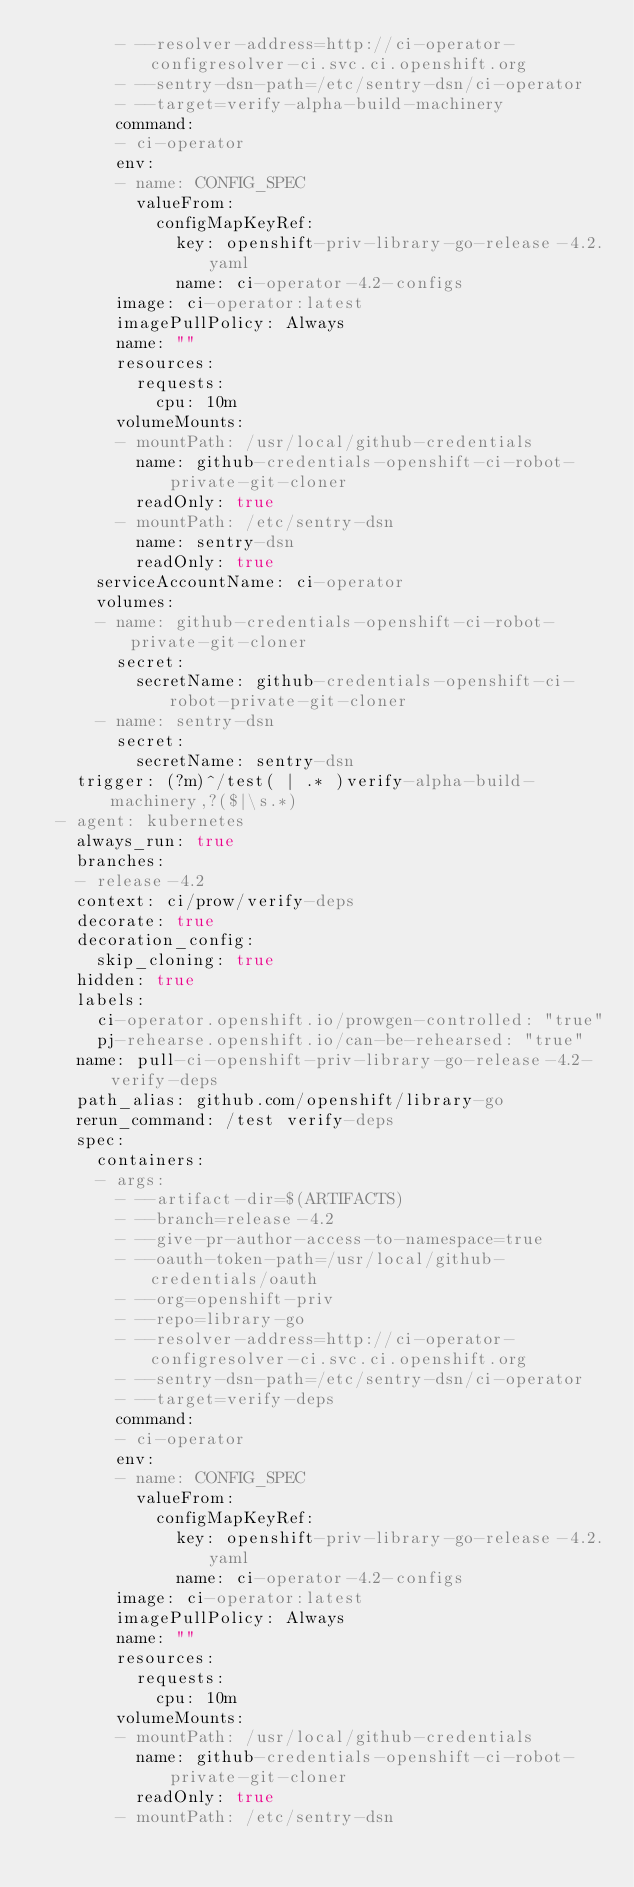<code> <loc_0><loc_0><loc_500><loc_500><_YAML_>        - --resolver-address=http://ci-operator-configresolver-ci.svc.ci.openshift.org
        - --sentry-dsn-path=/etc/sentry-dsn/ci-operator
        - --target=verify-alpha-build-machinery
        command:
        - ci-operator
        env:
        - name: CONFIG_SPEC
          valueFrom:
            configMapKeyRef:
              key: openshift-priv-library-go-release-4.2.yaml
              name: ci-operator-4.2-configs
        image: ci-operator:latest
        imagePullPolicy: Always
        name: ""
        resources:
          requests:
            cpu: 10m
        volumeMounts:
        - mountPath: /usr/local/github-credentials
          name: github-credentials-openshift-ci-robot-private-git-cloner
          readOnly: true
        - mountPath: /etc/sentry-dsn
          name: sentry-dsn
          readOnly: true
      serviceAccountName: ci-operator
      volumes:
      - name: github-credentials-openshift-ci-robot-private-git-cloner
        secret:
          secretName: github-credentials-openshift-ci-robot-private-git-cloner
      - name: sentry-dsn
        secret:
          secretName: sentry-dsn
    trigger: (?m)^/test( | .* )verify-alpha-build-machinery,?($|\s.*)
  - agent: kubernetes
    always_run: true
    branches:
    - release-4.2
    context: ci/prow/verify-deps
    decorate: true
    decoration_config:
      skip_cloning: true
    hidden: true
    labels:
      ci-operator.openshift.io/prowgen-controlled: "true"
      pj-rehearse.openshift.io/can-be-rehearsed: "true"
    name: pull-ci-openshift-priv-library-go-release-4.2-verify-deps
    path_alias: github.com/openshift/library-go
    rerun_command: /test verify-deps
    spec:
      containers:
      - args:
        - --artifact-dir=$(ARTIFACTS)
        - --branch=release-4.2
        - --give-pr-author-access-to-namespace=true
        - --oauth-token-path=/usr/local/github-credentials/oauth
        - --org=openshift-priv
        - --repo=library-go
        - --resolver-address=http://ci-operator-configresolver-ci.svc.ci.openshift.org
        - --sentry-dsn-path=/etc/sentry-dsn/ci-operator
        - --target=verify-deps
        command:
        - ci-operator
        env:
        - name: CONFIG_SPEC
          valueFrom:
            configMapKeyRef:
              key: openshift-priv-library-go-release-4.2.yaml
              name: ci-operator-4.2-configs
        image: ci-operator:latest
        imagePullPolicy: Always
        name: ""
        resources:
          requests:
            cpu: 10m
        volumeMounts:
        - mountPath: /usr/local/github-credentials
          name: github-credentials-openshift-ci-robot-private-git-cloner
          readOnly: true
        - mountPath: /etc/sentry-dsn</code> 